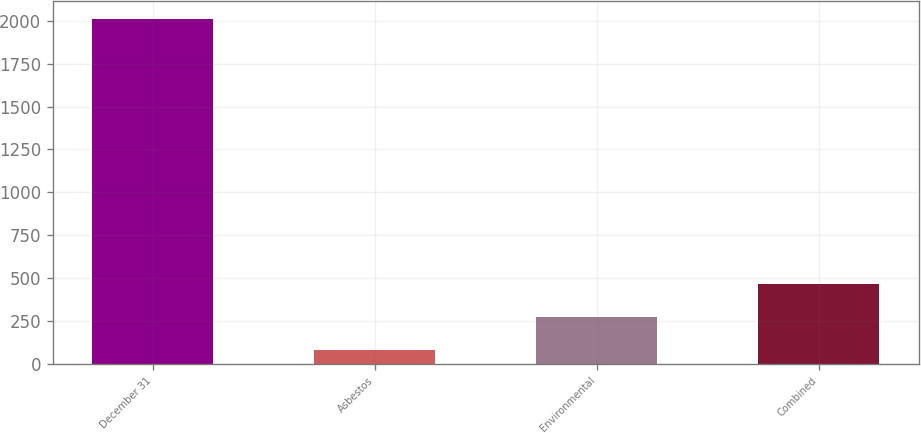<chart> <loc_0><loc_0><loc_500><loc_500><bar_chart><fcel>December 31<fcel>Asbestos<fcel>Environmental<fcel>Combined<nl><fcel>2014<fcel>79<fcel>272.5<fcel>466<nl></chart> 